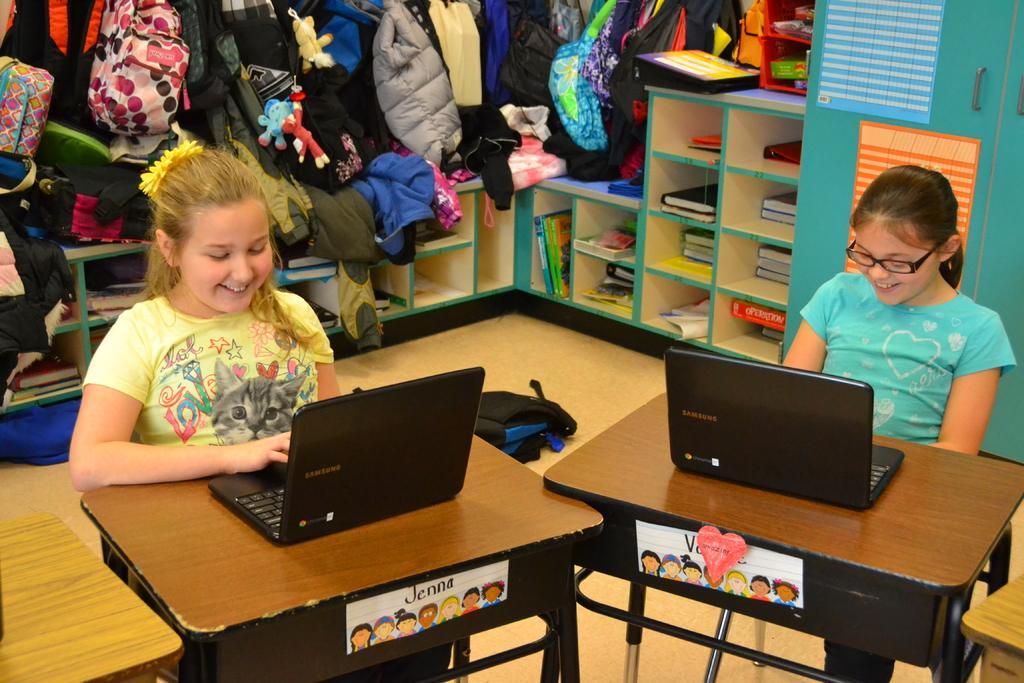Can you describe this image briefly? In this image there are two girls sitting on chair before a table having laptop on it. Girl at the right side is wearing a blue shirt and spectacles. Girl at the left side is wearing a yellow shirt. At the background there are few shelves having books and bags on it. 